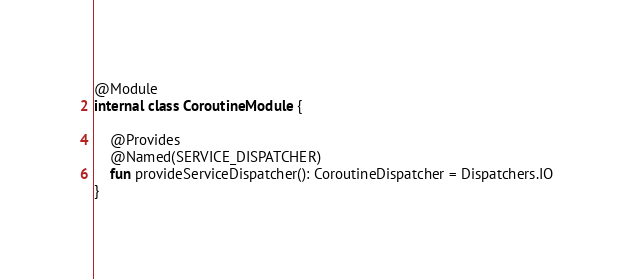<code> <loc_0><loc_0><loc_500><loc_500><_Kotlin_>
@Module
internal class CoroutineModule {

    @Provides
    @Named(SERVICE_DISPATCHER)
    fun provideServiceDispatcher(): CoroutineDispatcher = Dispatchers.IO
}
</code> 